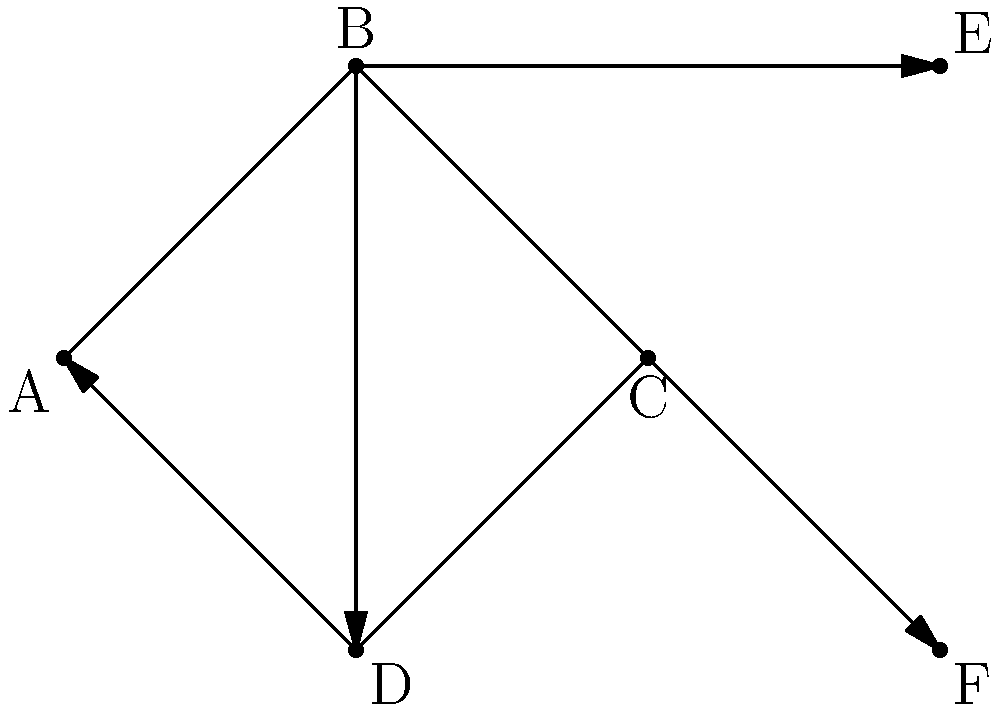In the social support network diagram above, each node represents a patient or support person, and directed edges represent support relationships. What is the in-degree of node B, and what does this value signify in terms of patient support? To answer this question, we need to follow these steps:

1. Understand the concept of in-degree in a directed graph:
   - The in-degree of a node is the number of edges pointing towards that node.

2. Examine node B in the given graph:
   - Look for all edges that have an arrowhead pointing towards node B.

3. Count the in-degree of node B:
   - We can see that there is only one edge pointing towards B, which comes from node A.

4. Interpret the meaning of the in-degree in the context of a social support network:
   - In this network, an edge pointing towards a node represents support received by that individual.
   - The in-degree represents the number of direct support sources for a given individual.

5. Relate the finding to patient support:
   - An in-degree of 1 for node B means that this individual (possibly a patient) receives direct support from only one source in the network.
   - This could indicate that the patient has a limited direct support system, which might be a concern for a family doctor advocating for comprehensive patient care.
Answer: 1; indicates limited direct support sources 